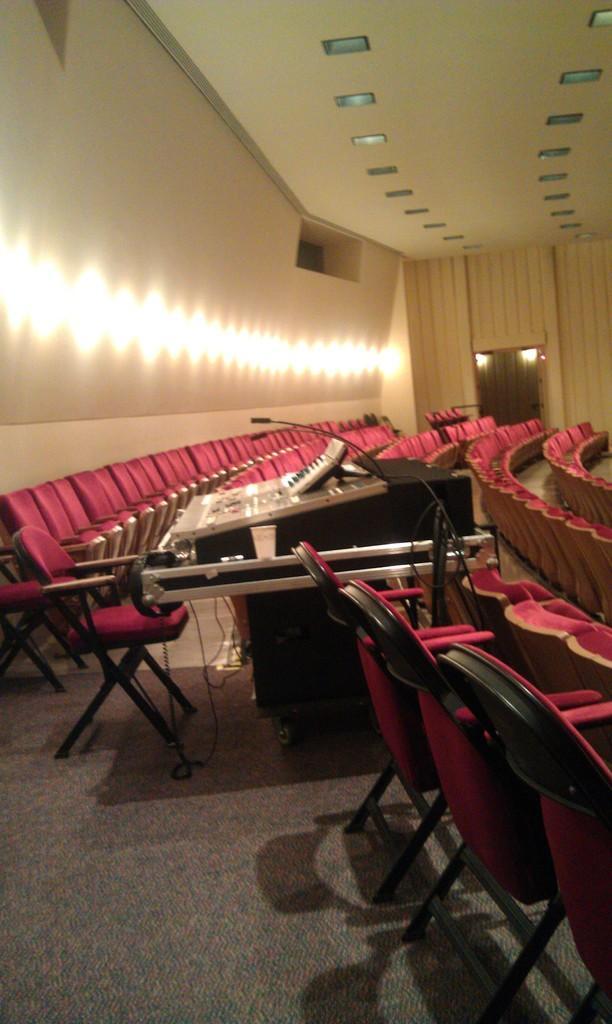Can you describe this image briefly? In this image, I can see the chairs. It looks like a table with the miles and few other objects on it. On the left side of the image, I think these are the lights on the wall. At the top of the image, I can see the ceiling lights, which are attached to the ceiling. At the bottom of the image, I can see the floor. 